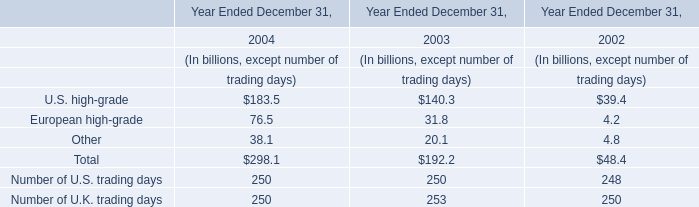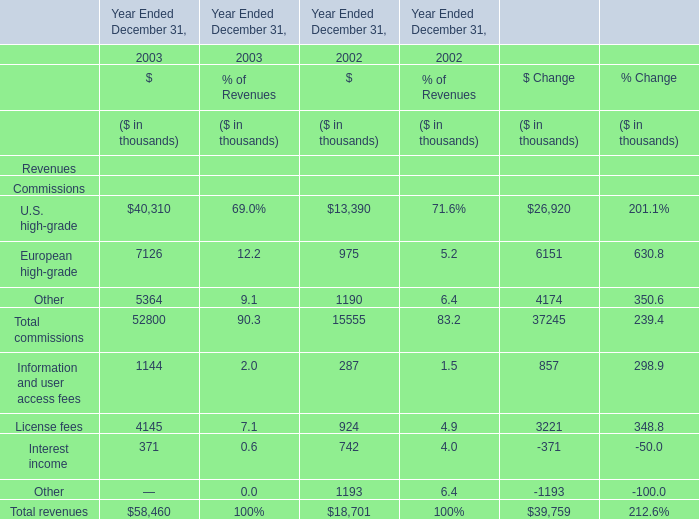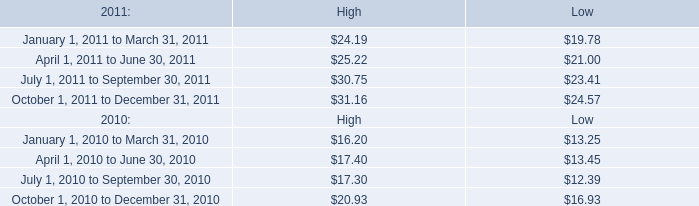based on the total holders of common stock as of february 16 , 2012 , what was the market share of mktx common stock? 
Computations: (32.65 * 41)
Answer: 1338.65. 